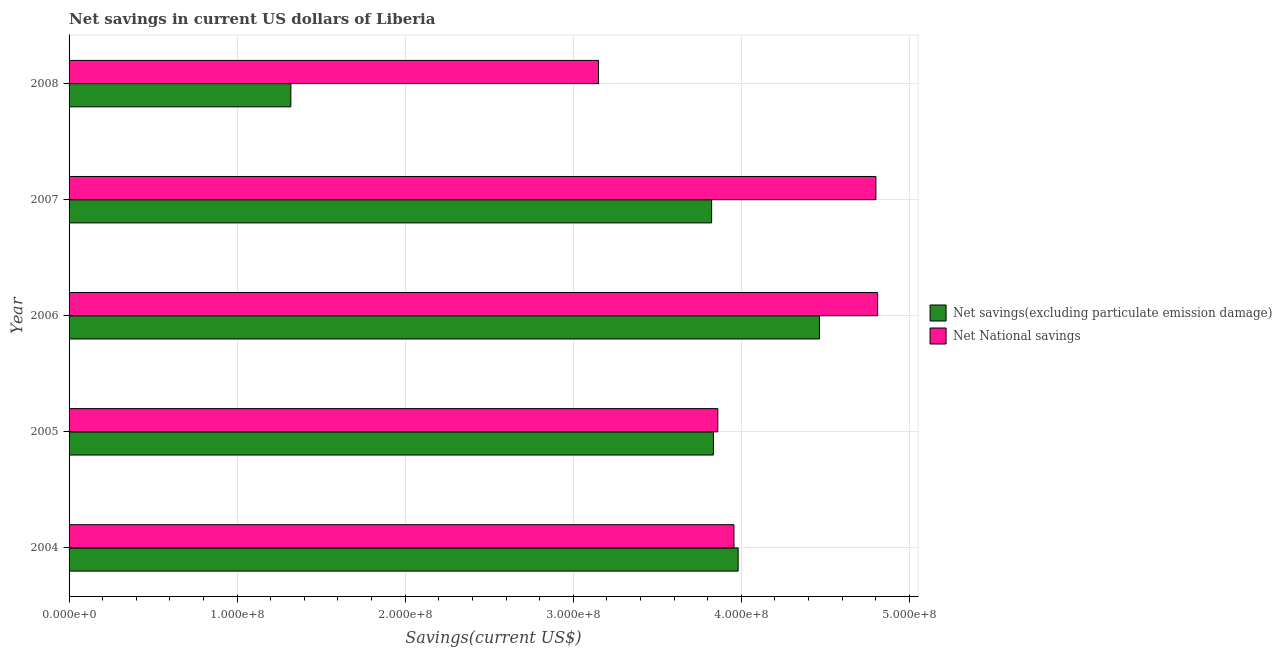Are the number of bars per tick equal to the number of legend labels?
Offer a very short reply. Yes. How many bars are there on the 2nd tick from the top?
Offer a very short reply. 2. What is the label of the 2nd group of bars from the top?
Your answer should be very brief. 2007. What is the net national savings in 2008?
Provide a succinct answer. 3.15e+08. Across all years, what is the maximum net savings(excluding particulate emission damage)?
Offer a very short reply. 4.46e+08. Across all years, what is the minimum net savings(excluding particulate emission damage)?
Your response must be concise. 1.32e+08. In which year was the net savings(excluding particulate emission damage) maximum?
Keep it short and to the point. 2006. In which year was the net savings(excluding particulate emission damage) minimum?
Give a very brief answer. 2008. What is the total net savings(excluding particulate emission damage) in the graph?
Keep it short and to the point. 1.74e+09. What is the difference between the net national savings in 2005 and that in 2006?
Keep it short and to the point. -9.51e+07. What is the difference between the net savings(excluding particulate emission damage) in 2008 and the net national savings in 2007?
Make the answer very short. -3.48e+08. What is the average net national savings per year?
Make the answer very short. 4.12e+08. In the year 2005, what is the difference between the net national savings and net savings(excluding particulate emission damage)?
Offer a terse response. 2.61e+06. What is the ratio of the net savings(excluding particulate emission damage) in 2005 to that in 2007?
Ensure brevity in your answer.  1. Is the net savings(excluding particulate emission damage) in 2004 less than that in 2007?
Ensure brevity in your answer.  No. What is the difference between the highest and the second highest net savings(excluding particulate emission damage)?
Make the answer very short. 4.84e+07. What is the difference between the highest and the lowest net national savings?
Give a very brief answer. 1.66e+08. In how many years, is the net savings(excluding particulate emission damage) greater than the average net savings(excluding particulate emission damage) taken over all years?
Offer a terse response. 4. What does the 2nd bar from the top in 2004 represents?
Provide a short and direct response. Net savings(excluding particulate emission damage). What does the 2nd bar from the bottom in 2004 represents?
Ensure brevity in your answer.  Net National savings. How many bars are there?
Give a very brief answer. 10. Are all the bars in the graph horizontal?
Give a very brief answer. Yes. How many years are there in the graph?
Your response must be concise. 5. Are the values on the major ticks of X-axis written in scientific E-notation?
Your response must be concise. Yes. Does the graph contain any zero values?
Offer a very short reply. No. Does the graph contain grids?
Your response must be concise. Yes. What is the title of the graph?
Your answer should be very brief. Net savings in current US dollars of Liberia. What is the label or title of the X-axis?
Keep it short and to the point. Savings(current US$). What is the Savings(current US$) in Net savings(excluding particulate emission damage) in 2004?
Provide a succinct answer. 3.98e+08. What is the Savings(current US$) of Net National savings in 2004?
Provide a short and direct response. 3.96e+08. What is the Savings(current US$) of Net savings(excluding particulate emission damage) in 2005?
Make the answer very short. 3.83e+08. What is the Savings(current US$) in Net National savings in 2005?
Provide a short and direct response. 3.86e+08. What is the Savings(current US$) of Net savings(excluding particulate emission damage) in 2006?
Offer a terse response. 4.46e+08. What is the Savings(current US$) in Net National savings in 2006?
Your answer should be very brief. 4.81e+08. What is the Savings(current US$) in Net savings(excluding particulate emission damage) in 2007?
Make the answer very short. 3.82e+08. What is the Savings(current US$) in Net National savings in 2007?
Offer a terse response. 4.80e+08. What is the Savings(current US$) of Net savings(excluding particulate emission damage) in 2008?
Ensure brevity in your answer.  1.32e+08. What is the Savings(current US$) in Net National savings in 2008?
Your response must be concise. 3.15e+08. Across all years, what is the maximum Savings(current US$) in Net savings(excluding particulate emission damage)?
Give a very brief answer. 4.46e+08. Across all years, what is the maximum Savings(current US$) in Net National savings?
Your response must be concise. 4.81e+08. Across all years, what is the minimum Savings(current US$) in Net savings(excluding particulate emission damage)?
Make the answer very short. 1.32e+08. Across all years, what is the minimum Savings(current US$) of Net National savings?
Keep it short and to the point. 3.15e+08. What is the total Savings(current US$) in Net savings(excluding particulate emission damage) in the graph?
Your response must be concise. 1.74e+09. What is the total Savings(current US$) in Net National savings in the graph?
Provide a short and direct response. 2.06e+09. What is the difference between the Savings(current US$) in Net savings(excluding particulate emission damage) in 2004 and that in 2005?
Give a very brief answer. 1.47e+07. What is the difference between the Savings(current US$) of Net National savings in 2004 and that in 2005?
Provide a succinct answer. 9.63e+06. What is the difference between the Savings(current US$) of Net savings(excluding particulate emission damage) in 2004 and that in 2006?
Offer a very short reply. -4.84e+07. What is the difference between the Savings(current US$) of Net National savings in 2004 and that in 2006?
Provide a short and direct response. -8.55e+07. What is the difference between the Savings(current US$) of Net savings(excluding particulate emission damage) in 2004 and that in 2007?
Provide a short and direct response. 1.58e+07. What is the difference between the Savings(current US$) in Net National savings in 2004 and that in 2007?
Your answer should be very brief. -8.44e+07. What is the difference between the Savings(current US$) of Net savings(excluding particulate emission damage) in 2004 and that in 2008?
Offer a very short reply. 2.66e+08. What is the difference between the Savings(current US$) of Net National savings in 2004 and that in 2008?
Provide a succinct answer. 8.06e+07. What is the difference between the Savings(current US$) of Net savings(excluding particulate emission damage) in 2005 and that in 2006?
Your response must be concise. -6.31e+07. What is the difference between the Savings(current US$) of Net National savings in 2005 and that in 2006?
Keep it short and to the point. -9.51e+07. What is the difference between the Savings(current US$) of Net savings(excluding particulate emission damage) in 2005 and that in 2007?
Provide a short and direct response. 1.06e+06. What is the difference between the Savings(current US$) of Net National savings in 2005 and that in 2007?
Give a very brief answer. -9.41e+07. What is the difference between the Savings(current US$) in Net savings(excluding particulate emission damage) in 2005 and that in 2008?
Make the answer very short. 2.51e+08. What is the difference between the Savings(current US$) of Net National savings in 2005 and that in 2008?
Your answer should be compact. 7.10e+07. What is the difference between the Savings(current US$) of Net savings(excluding particulate emission damage) in 2006 and that in 2007?
Make the answer very short. 6.42e+07. What is the difference between the Savings(current US$) of Net National savings in 2006 and that in 2007?
Keep it short and to the point. 1.03e+06. What is the difference between the Savings(current US$) of Net savings(excluding particulate emission damage) in 2006 and that in 2008?
Offer a very short reply. 3.15e+08. What is the difference between the Savings(current US$) in Net National savings in 2006 and that in 2008?
Keep it short and to the point. 1.66e+08. What is the difference between the Savings(current US$) of Net savings(excluding particulate emission damage) in 2007 and that in 2008?
Give a very brief answer. 2.50e+08. What is the difference between the Savings(current US$) in Net National savings in 2007 and that in 2008?
Provide a succinct answer. 1.65e+08. What is the difference between the Savings(current US$) of Net savings(excluding particulate emission damage) in 2004 and the Savings(current US$) of Net National savings in 2005?
Make the answer very short. 1.21e+07. What is the difference between the Savings(current US$) in Net savings(excluding particulate emission damage) in 2004 and the Savings(current US$) in Net National savings in 2006?
Your answer should be compact. -8.30e+07. What is the difference between the Savings(current US$) in Net savings(excluding particulate emission damage) in 2004 and the Savings(current US$) in Net National savings in 2007?
Your response must be concise. -8.20e+07. What is the difference between the Savings(current US$) of Net savings(excluding particulate emission damage) in 2004 and the Savings(current US$) of Net National savings in 2008?
Provide a short and direct response. 8.31e+07. What is the difference between the Savings(current US$) in Net savings(excluding particulate emission damage) in 2005 and the Savings(current US$) in Net National savings in 2006?
Your answer should be very brief. -9.77e+07. What is the difference between the Savings(current US$) of Net savings(excluding particulate emission damage) in 2005 and the Savings(current US$) of Net National savings in 2007?
Provide a succinct answer. -9.67e+07. What is the difference between the Savings(current US$) in Net savings(excluding particulate emission damage) in 2005 and the Savings(current US$) in Net National savings in 2008?
Your answer should be very brief. 6.84e+07. What is the difference between the Savings(current US$) of Net savings(excluding particulate emission damage) in 2006 and the Savings(current US$) of Net National savings in 2007?
Make the answer very short. -3.36e+07. What is the difference between the Savings(current US$) in Net savings(excluding particulate emission damage) in 2006 and the Savings(current US$) in Net National savings in 2008?
Provide a succinct answer. 1.31e+08. What is the difference between the Savings(current US$) of Net savings(excluding particulate emission damage) in 2007 and the Savings(current US$) of Net National savings in 2008?
Provide a succinct answer. 6.73e+07. What is the average Savings(current US$) of Net savings(excluding particulate emission damage) per year?
Keep it short and to the point. 3.48e+08. What is the average Savings(current US$) in Net National savings per year?
Your response must be concise. 4.12e+08. In the year 2004, what is the difference between the Savings(current US$) of Net savings(excluding particulate emission damage) and Savings(current US$) of Net National savings?
Make the answer very short. 2.49e+06. In the year 2005, what is the difference between the Savings(current US$) in Net savings(excluding particulate emission damage) and Savings(current US$) in Net National savings?
Provide a succinct answer. -2.61e+06. In the year 2006, what is the difference between the Savings(current US$) of Net savings(excluding particulate emission damage) and Savings(current US$) of Net National savings?
Provide a short and direct response. -3.46e+07. In the year 2007, what is the difference between the Savings(current US$) of Net savings(excluding particulate emission damage) and Savings(current US$) of Net National savings?
Your response must be concise. -9.77e+07. In the year 2008, what is the difference between the Savings(current US$) in Net savings(excluding particulate emission damage) and Savings(current US$) in Net National savings?
Your answer should be compact. -1.83e+08. What is the ratio of the Savings(current US$) in Net savings(excluding particulate emission damage) in 2004 to that in 2005?
Your answer should be compact. 1.04. What is the ratio of the Savings(current US$) in Net National savings in 2004 to that in 2005?
Provide a succinct answer. 1.02. What is the ratio of the Savings(current US$) of Net savings(excluding particulate emission damage) in 2004 to that in 2006?
Provide a short and direct response. 0.89. What is the ratio of the Savings(current US$) in Net National savings in 2004 to that in 2006?
Make the answer very short. 0.82. What is the ratio of the Savings(current US$) of Net savings(excluding particulate emission damage) in 2004 to that in 2007?
Ensure brevity in your answer.  1.04. What is the ratio of the Savings(current US$) of Net National savings in 2004 to that in 2007?
Offer a terse response. 0.82. What is the ratio of the Savings(current US$) of Net savings(excluding particulate emission damage) in 2004 to that in 2008?
Your answer should be very brief. 3.02. What is the ratio of the Savings(current US$) in Net National savings in 2004 to that in 2008?
Your answer should be compact. 1.26. What is the ratio of the Savings(current US$) in Net savings(excluding particulate emission damage) in 2005 to that in 2006?
Offer a very short reply. 0.86. What is the ratio of the Savings(current US$) of Net National savings in 2005 to that in 2006?
Offer a very short reply. 0.8. What is the ratio of the Savings(current US$) in Net savings(excluding particulate emission damage) in 2005 to that in 2007?
Offer a very short reply. 1. What is the ratio of the Savings(current US$) of Net National savings in 2005 to that in 2007?
Provide a short and direct response. 0.8. What is the ratio of the Savings(current US$) in Net savings(excluding particulate emission damage) in 2005 to that in 2008?
Make the answer very short. 2.91. What is the ratio of the Savings(current US$) of Net National savings in 2005 to that in 2008?
Offer a terse response. 1.23. What is the ratio of the Savings(current US$) in Net savings(excluding particulate emission damage) in 2006 to that in 2007?
Keep it short and to the point. 1.17. What is the ratio of the Savings(current US$) in Net National savings in 2006 to that in 2007?
Ensure brevity in your answer.  1. What is the ratio of the Savings(current US$) in Net savings(excluding particulate emission damage) in 2006 to that in 2008?
Provide a succinct answer. 3.38. What is the ratio of the Savings(current US$) in Net National savings in 2006 to that in 2008?
Provide a succinct answer. 1.53. What is the ratio of the Savings(current US$) of Net savings(excluding particulate emission damage) in 2007 to that in 2008?
Your answer should be very brief. 2.9. What is the ratio of the Savings(current US$) in Net National savings in 2007 to that in 2008?
Provide a succinct answer. 1.52. What is the difference between the highest and the second highest Savings(current US$) in Net savings(excluding particulate emission damage)?
Provide a succinct answer. 4.84e+07. What is the difference between the highest and the second highest Savings(current US$) of Net National savings?
Give a very brief answer. 1.03e+06. What is the difference between the highest and the lowest Savings(current US$) of Net savings(excluding particulate emission damage)?
Ensure brevity in your answer.  3.15e+08. What is the difference between the highest and the lowest Savings(current US$) in Net National savings?
Provide a short and direct response. 1.66e+08. 